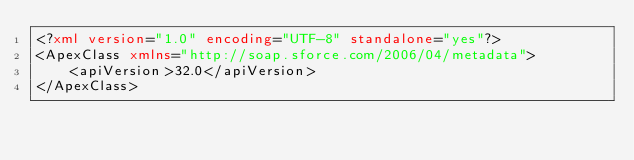Convert code to text. <code><loc_0><loc_0><loc_500><loc_500><_XML_><?xml version="1.0" encoding="UTF-8" standalone="yes"?>
<ApexClass xmlns="http://soap.sforce.com/2006/04/metadata">
    <apiVersion>32.0</apiVersion>
</ApexClass>
</code> 